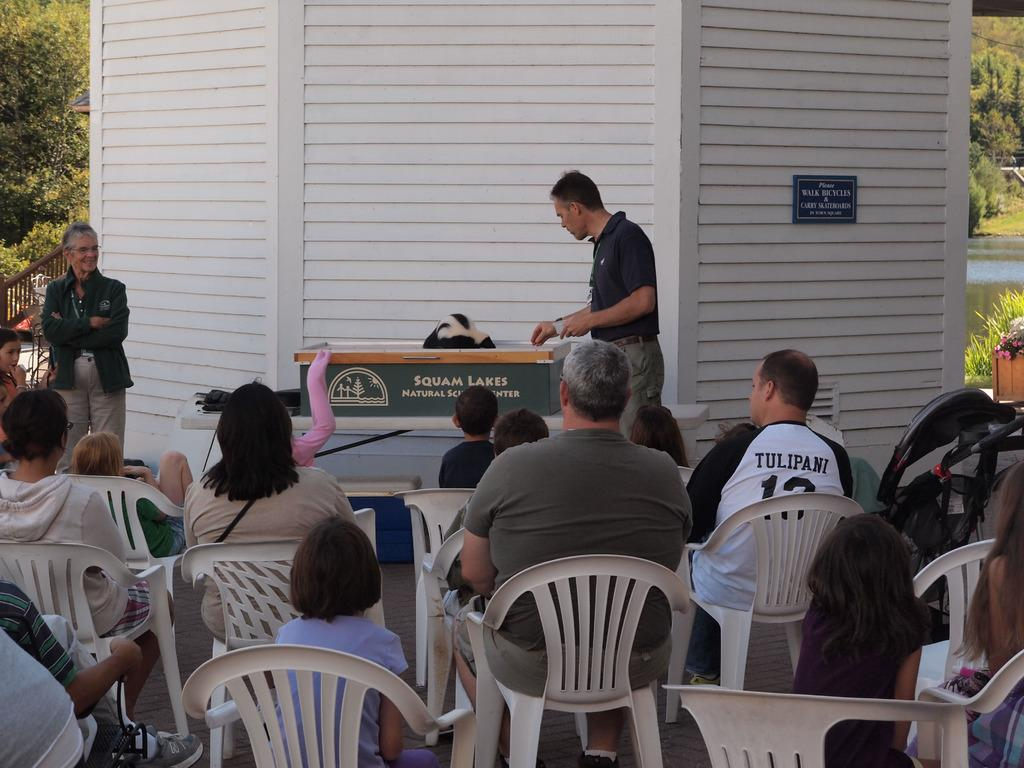<image>
Write a terse but informative summary of the picture. A Squam Lakes presentation with families in the audience. 